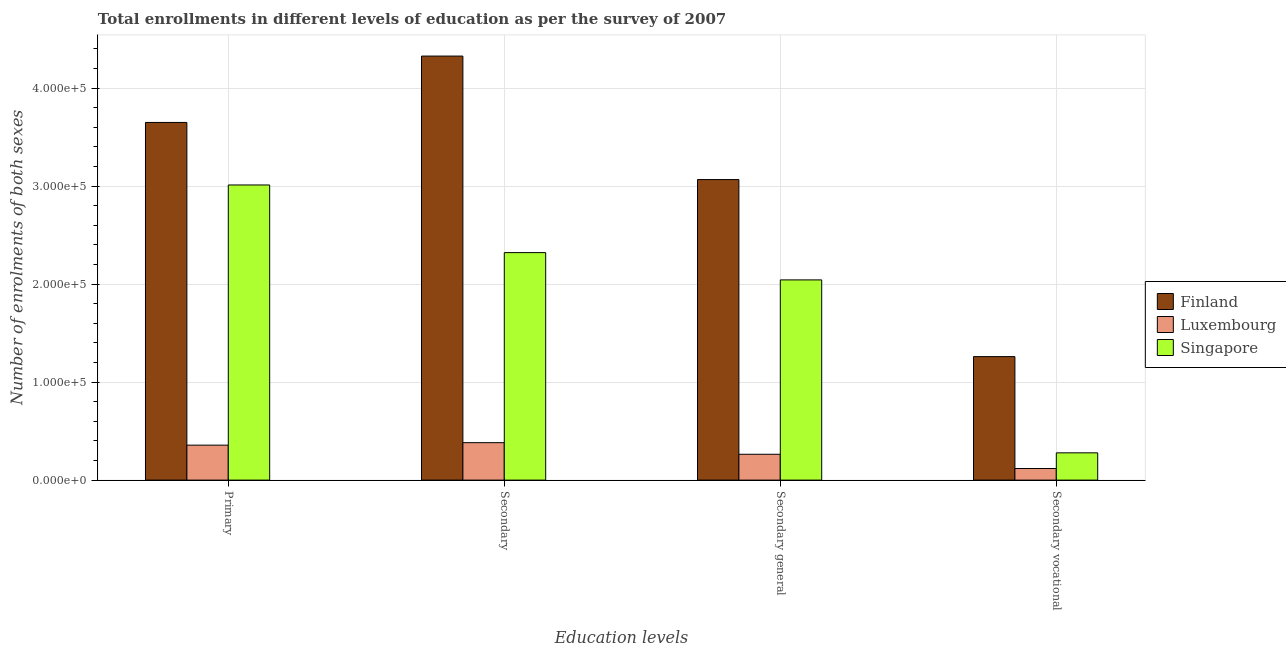How many groups of bars are there?
Offer a very short reply. 4. How many bars are there on the 1st tick from the left?
Your response must be concise. 3. What is the label of the 2nd group of bars from the left?
Your response must be concise. Secondary. What is the number of enrolments in secondary vocational education in Luxembourg?
Make the answer very short. 1.18e+04. Across all countries, what is the maximum number of enrolments in secondary general education?
Keep it short and to the point. 3.07e+05. Across all countries, what is the minimum number of enrolments in secondary general education?
Make the answer very short. 2.64e+04. In which country was the number of enrolments in secondary education maximum?
Give a very brief answer. Finland. In which country was the number of enrolments in secondary vocational education minimum?
Provide a succinct answer. Luxembourg. What is the total number of enrolments in secondary education in the graph?
Ensure brevity in your answer.  7.03e+05. What is the difference between the number of enrolments in secondary general education in Singapore and that in Luxembourg?
Keep it short and to the point. 1.78e+05. What is the difference between the number of enrolments in secondary education in Singapore and the number of enrolments in secondary general education in Finland?
Your answer should be compact. -7.45e+04. What is the average number of enrolments in secondary education per country?
Give a very brief answer. 2.34e+05. What is the difference between the number of enrolments in secondary general education and number of enrolments in primary education in Luxembourg?
Provide a short and direct response. -9302. What is the ratio of the number of enrolments in secondary education in Luxembourg to that in Singapore?
Provide a succinct answer. 0.16. Is the number of enrolments in secondary education in Singapore less than that in Luxembourg?
Your response must be concise. No. What is the difference between the highest and the second highest number of enrolments in secondary education?
Provide a short and direct response. 2.01e+05. What is the difference between the highest and the lowest number of enrolments in secondary vocational education?
Your response must be concise. 1.14e+05. Is the sum of the number of enrolments in primary education in Finland and Luxembourg greater than the maximum number of enrolments in secondary education across all countries?
Give a very brief answer. No. What does the 3rd bar from the left in Secondary general represents?
Your answer should be very brief. Singapore. Are all the bars in the graph horizontal?
Ensure brevity in your answer.  No. Are the values on the major ticks of Y-axis written in scientific E-notation?
Make the answer very short. Yes. Does the graph contain any zero values?
Your answer should be very brief. No. How are the legend labels stacked?
Keep it short and to the point. Vertical. What is the title of the graph?
Your answer should be compact. Total enrollments in different levels of education as per the survey of 2007. Does "Turks and Caicos Islands" appear as one of the legend labels in the graph?
Make the answer very short. No. What is the label or title of the X-axis?
Offer a terse response. Education levels. What is the label or title of the Y-axis?
Provide a succinct answer. Number of enrolments of both sexes. What is the Number of enrolments of both sexes in Finland in Primary?
Offer a terse response. 3.65e+05. What is the Number of enrolments of both sexes in Luxembourg in Primary?
Your answer should be compact. 3.57e+04. What is the Number of enrolments of both sexes of Singapore in Primary?
Offer a very short reply. 3.01e+05. What is the Number of enrolments of both sexes of Finland in Secondary?
Make the answer very short. 4.33e+05. What is the Number of enrolments of both sexes of Luxembourg in Secondary?
Offer a very short reply. 3.82e+04. What is the Number of enrolments of both sexes in Singapore in Secondary?
Your answer should be very brief. 2.32e+05. What is the Number of enrolments of both sexes in Finland in Secondary general?
Ensure brevity in your answer.  3.07e+05. What is the Number of enrolments of both sexes of Luxembourg in Secondary general?
Give a very brief answer. 2.64e+04. What is the Number of enrolments of both sexes in Singapore in Secondary general?
Give a very brief answer. 2.04e+05. What is the Number of enrolments of both sexes of Finland in Secondary vocational?
Make the answer very short. 1.26e+05. What is the Number of enrolments of both sexes of Luxembourg in Secondary vocational?
Ensure brevity in your answer.  1.18e+04. What is the Number of enrolments of both sexes in Singapore in Secondary vocational?
Your answer should be very brief. 2.78e+04. Across all Education levels, what is the maximum Number of enrolments of both sexes in Finland?
Ensure brevity in your answer.  4.33e+05. Across all Education levels, what is the maximum Number of enrolments of both sexes in Luxembourg?
Provide a succinct answer. 3.82e+04. Across all Education levels, what is the maximum Number of enrolments of both sexes in Singapore?
Provide a short and direct response. 3.01e+05. Across all Education levels, what is the minimum Number of enrolments of both sexes of Finland?
Your answer should be compact. 1.26e+05. Across all Education levels, what is the minimum Number of enrolments of both sexes of Luxembourg?
Provide a succinct answer. 1.18e+04. Across all Education levels, what is the minimum Number of enrolments of both sexes of Singapore?
Provide a succinct answer. 2.78e+04. What is the total Number of enrolments of both sexes in Finland in the graph?
Your answer should be very brief. 1.23e+06. What is the total Number of enrolments of both sexes in Luxembourg in the graph?
Give a very brief answer. 1.12e+05. What is the total Number of enrolments of both sexes in Singapore in the graph?
Your response must be concise. 7.65e+05. What is the difference between the Number of enrolments of both sexes in Finland in Primary and that in Secondary?
Your response must be concise. -6.77e+04. What is the difference between the Number of enrolments of both sexes of Luxembourg in Primary and that in Secondary?
Offer a very short reply. -2541. What is the difference between the Number of enrolments of both sexes of Singapore in Primary and that in Secondary?
Ensure brevity in your answer.  6.90e+04. What is the difference between the Number of enrolments of both sexes in Finland in Primary and that in Secondary general?
Your answer should be compact. 5.83e+04. What is the difference between the Number of enrolments of both sexes of Luxembourg in Primary and that in Secondary general?
Give a very brief answer. 9302. What is the difference between the Number of enrolments of both sexes of Singapore in Primary and that in Secondary general?
Your response must be concise. 9.68e+04. What is the difference between the Number of enrolments of both sexes in Finland in Primary and that in Secondary vocational?
Provide a succinct answer. 2.39e+05. What is the difference between the Number of enrolments of both sexes in Luxembourg in Primary and that in Secondary vocational?
Provide a short and direct response. 2.38e+04. What is the difference between the Number of enrolments of both sexes of Singapore in Primary and that in Secondary vocational?
Your answer should be very brief. 2.73e+05. What is the difference between the Number of enrolments of both sexes of Finland in Secondary and that in Secondary general?
Ensure brevity in your answer.  1.26e+05. What is the difference between the Number of enrolments of both sexes of Luxembourg in Secondary and that in Secondary general?
Offer a terse response. 1.18e+04. What is the difference between the Number of enrolments of both sexes in Singapore in Secondary and that in Secondary general?
Provide a short and direct response. 2.78e+04. What is the difference between the Number of enrolments of both sexes of Finland in Secondary and that in Secondary vocational?
Your answer should be compact. 3.07e+05. What is the difference between the Number of enrolments of both sexes in Luxembourg in Secondary and that in Secondary vocational?
Give a very brief answer. 2.64e+04. What is the difference between the Number of enrolments of both sexes in Singapore in Secondary and that in Secondary vocational?
Make the answer very short. 2.04e+05. What is the difference between the Number of enrolments of both sexes in Finland in Secondary general and that in Secondary vocational?
Your answer should be very brief. 1.81e+05. What is the difference between the Number of enrolments of both sexes of Luxembourg in Secondary general and that in Secondary vocational?
Offer a very short reply. 1.45e+04. What is the difference between the Number of enrolments of both sexes of Singapore in Secondary general and that in Secondary vocational?
Offer a terse response. 1.76e+05. What is the difference between the Number of enrolments of both sexes of Finland in Primary and the Number of enrolments of both sexes of Luxembourg in Secondary?
Offer a terse response. 3.27e+05. What is the difference between the Number of enrolments of both sexes of Finland in Primary and the Number of enrolments of both sexes of Singapore in Secondary?
Provide a succinct answer. 1.33e+05. What is the difference between the Number of enrolments of both sexes of Luxembourg in Primary and the Number of enrolments of both sexes of Singapore in Secondary?
Provide a short and direct response. -1.96e+05. What is the difference between the Number of enrolments of both sexes of Finland in Primary and the Number of enrolments of both sexes of Luxembourg in Secondary general?
Make the answer very short. 3.39e+05. What is the difference between the Number of enrolments of both sexes in Finland in Primary and the Number of enrolments of both sexes in Singapore in Secondary general?
Your answer should be compact. 1.61e+05. What is the difference between the Number of enrolments of both sexes of Luxembourg in Primary and the Number of enrolments of both sexes of Singapore in Secondary general?
Keep it short and to the point. -1.69e+05. What is the difference between the Number of enrolments of both sexes of Finland in Primary and the Number of enrolments of both sexes of Luxembourg in Secondary vocational?
Offer a terse response. 3.53e+05. What is the difference between the Number of enrolments of both sexes of Finland in Primary and the Number of enrolments of both sexes of Singapore in Secondary vocational?
Keep it short and to the point. 3.37e+05. What is the difference between the Number of enrolments of both sexes of Luxembourg in Primary and the Number of enrolments of both sexes of Singapore in Secondary vocational?
Offer a terse response. 7837. What is the difference between the Number of enrolments of both sexes in Finland in Secondary and the Number of enrolments of both sexes in Luxembourg in Secondary general?
Provide a succinct answer. 4.06e+05. What is the difference between the Number of enrolments of both sexes of Finland in Secondary and the Number of enrolments of both sexes of Singapore in Secondary general?
Offer a very short reply. 2.28e+05. What is the difference between the Number of enrolments of both sexes in Luxembourg in Secondary and the Number of enrolments of both sexes in Singapore in Secondary general?
Provide a succinct answer. -1.66e+05. What is the difference between the Number of enrolments of both sexes of Finland in Secondary and the Number of enrolments of both sexes of Luxembourg in Secondary vocational?
Your answer should be very brief. 4.21e+05. What is the difference between the Number of enrolments of both sexes of Finland in Secondary and the Number of enrolments of both sexes of Singapore in Secondary vocational?
Your answer should be very brief. 4.05e+05. What is the difference between the Number of enrolments of both sexes of Luxembourg in Secondary and the Number of enrolments of both sexes of Singapore in Secondary vocational?
Your answer should be very brief. 1.04e+04. What is the difference between the Number of enrolments of both sexes in Finland in Secondary general and the Number of enrolments of both sexes in Luxembourg in Secondary vocational?
Provide a succinct answer. 2.95e+05. What is the difference between the Number of enrolments of both sexes in Finland in Secondary general and the Number of enrolments of both sexes in Singapore in Secondary vocational?
Offer a very short reply. 2.79e+05. What is the difference between the Number of enrolments of both sexes in Luxembourg in Secondary general and the Number of enrolments of both sexes in Singapore in Secondary vocational?
Give a very brief answer. -1465. What is the average Number of enrolments of both sexes of Finland per Education levels?
Your response must be concise. 3.08e+05. What is the average Number of enrolments of both sexes in Luxembourg per Education levels?
Provide a succinct answer. 2.80e+04. What is the average Number of enrolments of both sexes in Singapore per Education levels?
Ensure brevity in your answer.  1.91e+05. What is the difference between the Number of enrolments of both sexes of Finland and Number of enrolments of both sexes of Luxembourg in Primary?
Offer a terse response. 3.29e+05. What is the difference between the Number of enrolments of both sexes in Finland and Number of enrolments of both sexes in Singapore in Primary?
Provide a short and direct response. 6.38e+04. What is the difference between the Number of enrolments of both sexes in Luxembourg and Number of enrolments of both sexes in Singapore in Primary?
Keep it short and to the point. -2.65e+05. What is the difference between the Number of enrolments of both sexes in Finland and Number of enrolments of both sexes in Luxembourg in Secondary?
Provide a succinct answer. 3.94e+05. What is the difference between the Number of enrolments of both sexes in Finland and Number of enrolments of both sexes in Singapore in Secondary?
Offer a terse response. 2.01e+05. What is the difference between the Number of enrolments of both sexes of Luxembourg and Number of enrolments of both sexes of Singapore in Secondary?
Offer a very short reply. -1.94e+05. What is the difference between the Number of enrolments of both sexes in Finland and Number of enrolments of both sexes in Luxembourg in Secondary general?
Offer a very short reply. 2.80e+05. What is the difference between the Number of enrolments of both sexes of Finland and Number of enrolments of both sexes of Singapore in Secondary general?
Provide a short and direct response. 1.02e+05. What is the difference between the Number of enrolments of both sexes in Luxembourg and Number of enrolments of both sexes in Singapore in Secondary general?
Your answer should be very brief. -1.78e+05. What is the difference between the Number of enrolments of both sexes of Finland and Number of enrolments of both sexes of Luxembourg in Secondary vocational?
Keep it short and to the point. 1.14e+05. What is the difference between the Number of enrolments of both sexes of Finland and Number of enrolments of both sexes of Singapore in Secondary vocational?
Your answer should be very brief. 9.82e+04. What is the difference between the Number of enrolments of both sexes in Luxembourg and Number of enrolments of both sexes in Singapore in Secondary vocational?
Offer a very short reply. -1.60e+04. What is the ratio of the Number of enrolments of both sexes in Finland in Primary to that in Secondary?
Provide a short and direct response. 0.84. What is the ratio of the Number of enrolments of both sexes in Luxembourg in Primary to that in Secondary?
Give a very brief answer. 0.93. What is the ratio of the Number of enrolments of both sexes of Singapore in Primary to that in Secondary?
Offer a very short reply. 1.3. What is the ratio of the Number of enrolments of both sexes of Finland in Primary to that in Secondary general?
Offer a terse response. 1.19. What is the ratio of the Number of enrolments of both sexes in Luxembourg in Primary to that in Secondary general?
Give a very brief answer. 1.35. What is the ratio of the Number of enrolments of both sexes of Singapore in Primary to that in Secondary general?
Give a very brief answer. 1.47. What is the ratio of the Number of enrolments of both sexes in Finland in Primary to that in Secondary vocational?
Ensure brevity in your answer.  2.9. What is the ratio of the Number of enrolments of both sexes of Luxembourg in Primary to that in Secondary vocational?
Provide a succinct answer. 3.01. What is the ratio of the Number of enrolments of both sexes of Singapore in Primary to that in Secondary vocational?
Keep it short and to the point. 10.82. What is the ratio of the Number of enrolments of both sexes of Finland in Secondary to that in Secondary general?
Offer a terse response. 1.41. What is the ratio of the Number of enrolments of both sexes of Luxembourg in Secondary to that in Secondary general?
Provide a short and direct response. 1.45. What is the ratio of the Number of enrolments of both sexes in Singapore in Secondary to that in Secondary general?
Offer a very short reply. 1.14. What is the ratio of the Number of enrolments of both sexes of Finland in Secondary to that in Secondary vocational?
Give a very brief answer. 3.43. What is the ratio of the Number of enrolments of both sexes in Luxembourg in Secondary to that in Secondary vocational?
Your answer should be compact. 3.23. What is the ratio of the Number of enrolments of both sexes in Singapore in Secondary to that in Secondary vocational?
Provide a succinct answer. 8.34. What is the ratio of the Number of enrolments of both sexes of Finland in Secondary general to that in Secondary vocational?
Give a very brief answer. 2.43. What is the ratio of the Number of enrolments of both sexes in Luxembourg in Secondary general to that in Secondary vocational?
Provide a succinct answer. 2.23. What is the ratio of the Number of enrolments of both sexes in Singapore in Secondary general to that in Secondary vocational?
Provide a succinct answer. 7.34. What is the difference between the highest and the second highest Number of enrolments of both sexes of Finland?
Provide a short and direct response. 6.77e+04. What is the difference between the highest and the second highest Number of enrolments of both sexes of Luxembourg?
Provide a short and direct response. 2541. What is the difference between the highest and the second highest Number of enrolments of both sexes of Singapore?
Provide a short and direct response. 6.90e+04. What is the difference between the highest and the lowest Number of enrolments of both sexes of Finland?
Give a very brief answer. 3.07e+05. What is the difference between the highest and the lowest Number of enrolments of both sexes of Luxembourg?
Your response must be concise. 2.64e+04. What is the difference between the highest and the lowest Number of enrolments of both sexes of Singapore?
Your answer should be very brief. 2.73e+05. 